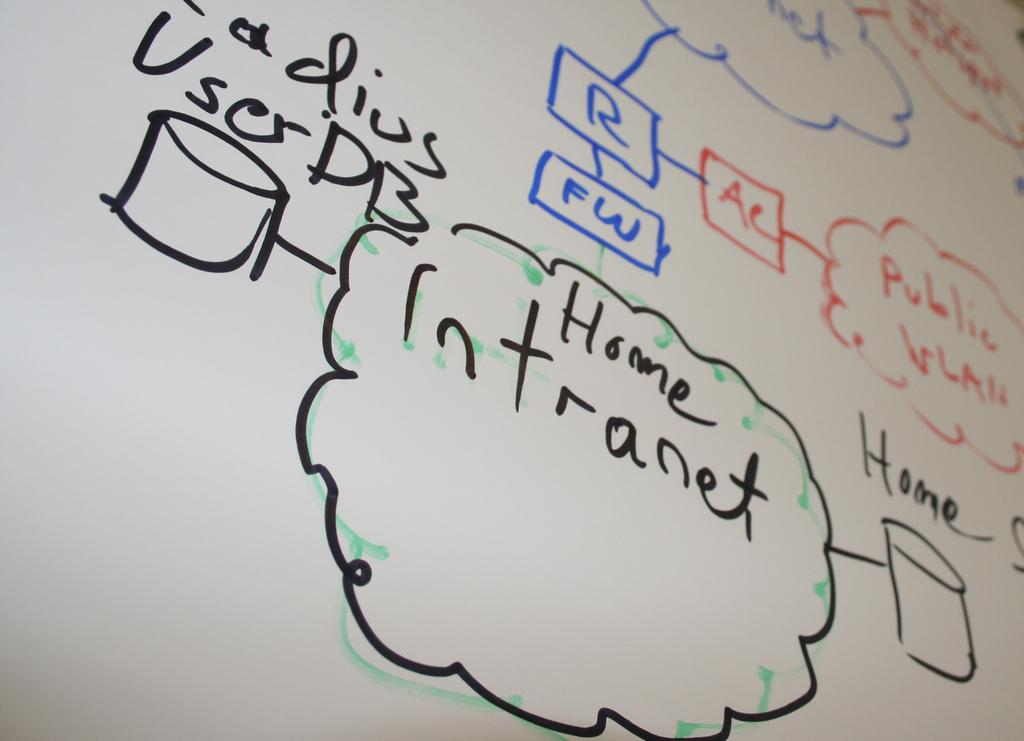Provide a one-sentence caption for the provided image. White board with flow chart showing a user's internet activity, including Home Intranet and Radius User DB as part of chart. 